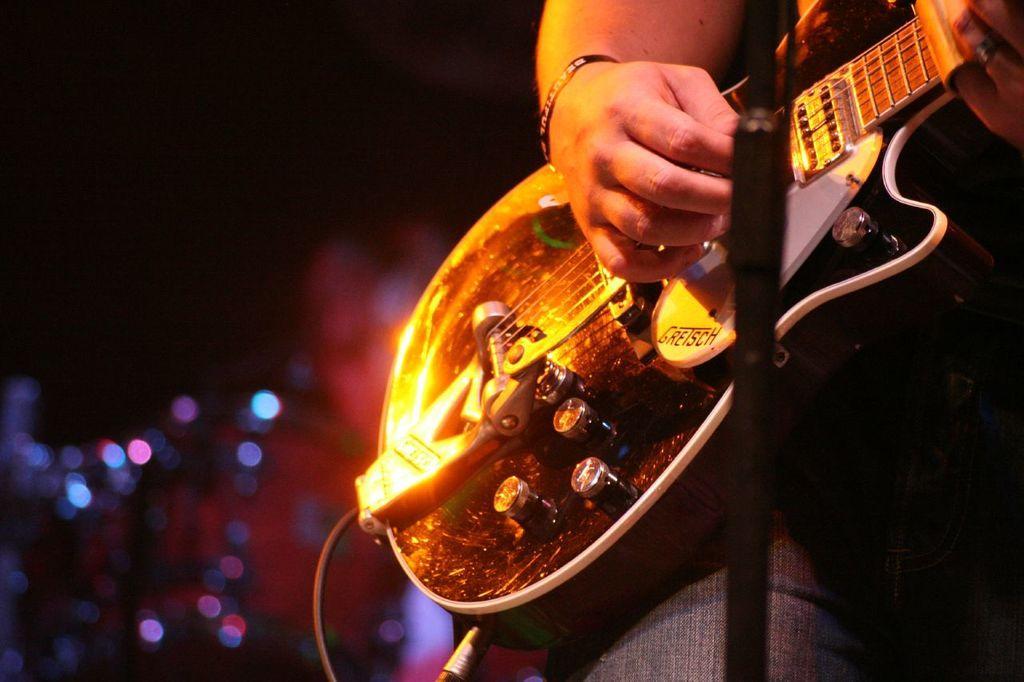Could you give a brief overview of what you see in this image? in this image the person is playing the guitar and he is holding the guitar and he is wearing the band and the background is very dark. 